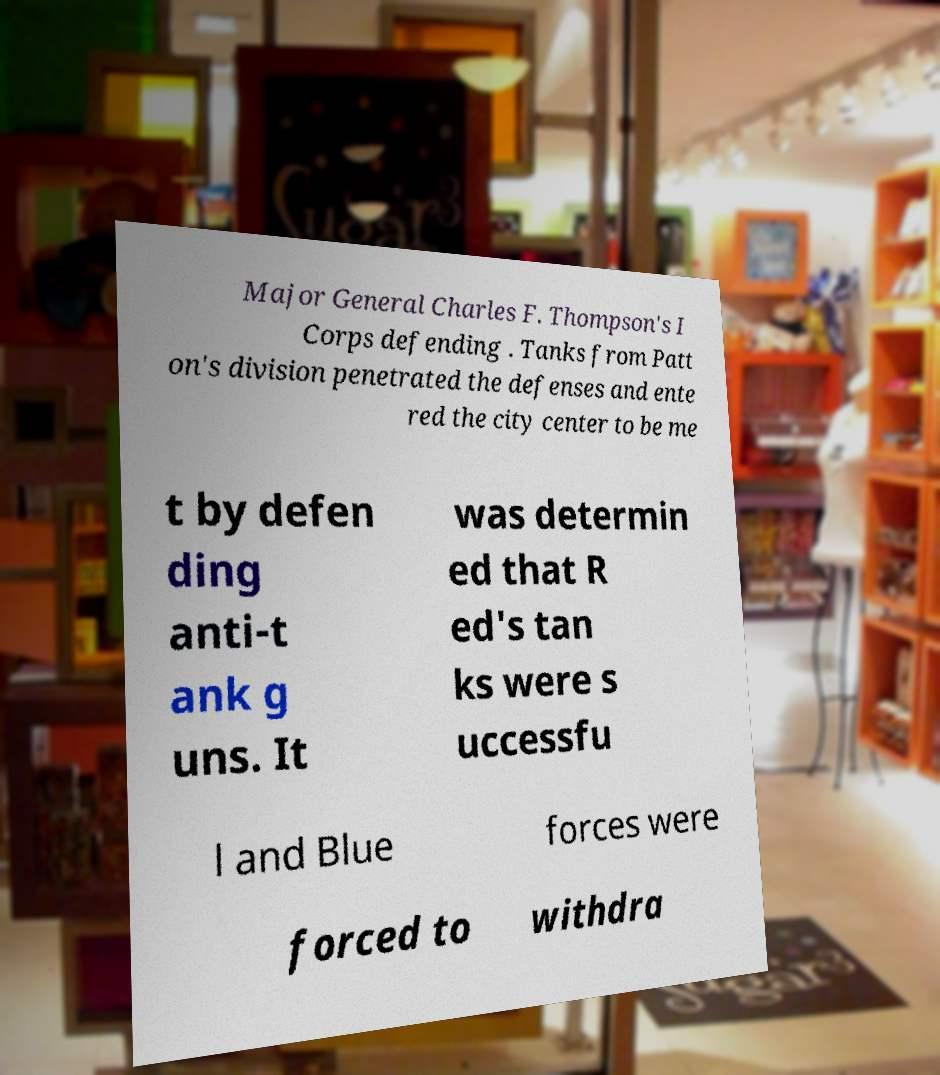There's text embedded in this image that I need extracted. Can you transcribe it verbatim? Major General Charles F. Thompson's I Corps defending . Tanks from Patt on's division penetrated the defenses and ente red the city center to be me t by defen ding anti-t ank g uns. It was determin ed that R ed's tan ks were s uccessfu l and Blue forces were forced to withdra 